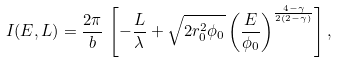Convert formula to latex. <formula><loc_0><loc_0><loc_500><loc_500>I ( E , L ) = \frac { 2 \pi } { b } \, \left [ - \frac { L } { \lambda } + \sqrt { 2 r _ { 0 } ^ { 2 } \phi _ { 0 } } \left ( \frac { E } { \phi _ { 0 } } \right ) ^ { \frac { 4 - \gamma } { 2 ( 2 - \gamma ) } } \right ] ,</formula> 